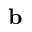Convert formula to latex. <formula><loc_0><loc_0><loc_500><loc_500>b</formula> 